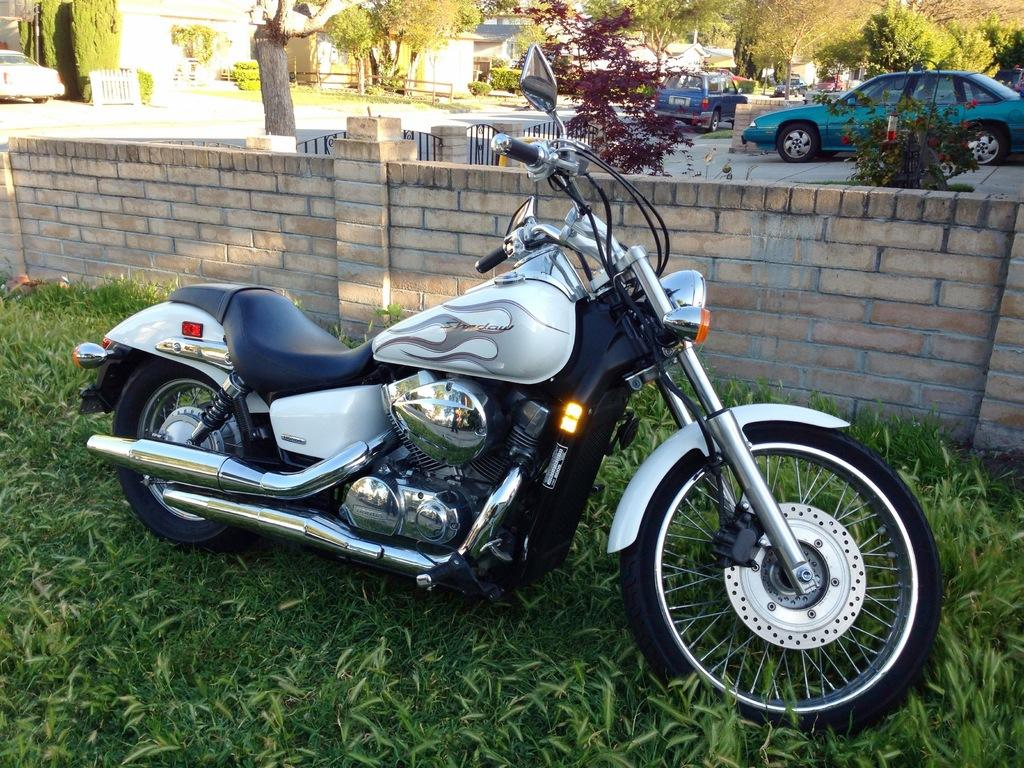What is the main object in the image? There is a bike in the image. What can be seen behind the bike? There is a fence in the image. What type of terrain is visible in the image? There is grass visible in the image. What can be seen in the distance in the image? There are cars, trees, and houses in the background of the image. How many pigs are visible in the image? There are no pigs present in the image. What is the aftermath of the bike accident in the image? There is no bike accident depicted in the image, so there is no aftermath to discuss. 